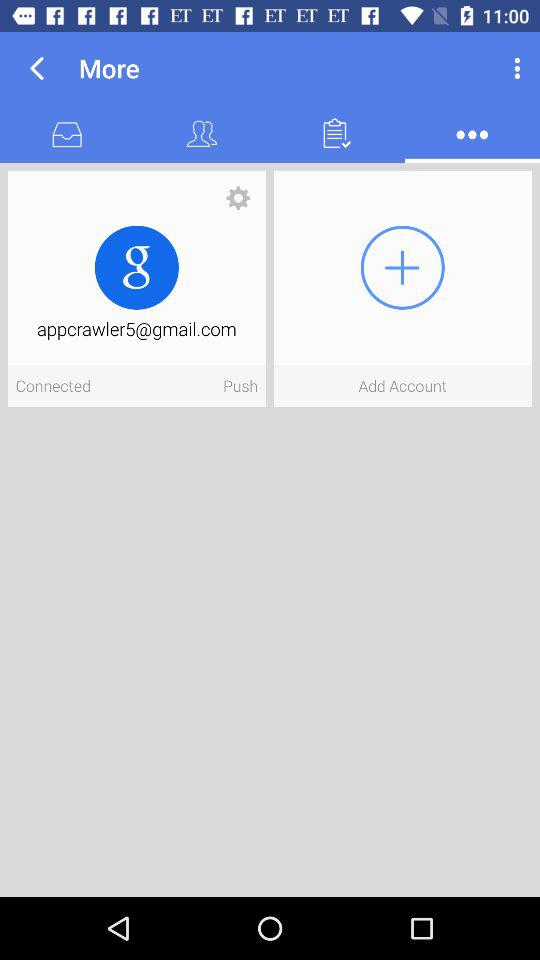What is the email address? The email address is appcrawler5@gmail.com. 